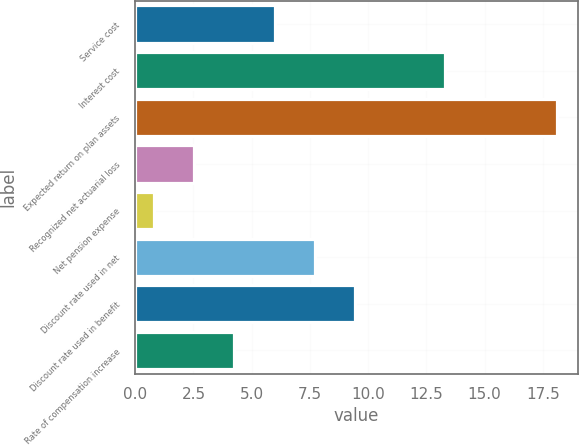Convert chart to OTSL. <chart><loc_0><loc_0><loc_500><loc_500><bar_chart><fcel>Service cost<fcel>Interest cost<fcel>Expected return on plan assets<fcel>Recognized net actuarial loss<fcel>Net pension expense<fcel>Discount rate used in net<fcel>Discount rate used in benefit<fcel>Rate of compensation increase<nl><fcel>5.99<fcel>13.3<fcel>18.1<fcel>2.53<fcel>0.8<fcel>7.72<fcel>9.45<fcel>4.26<nl></chart> 